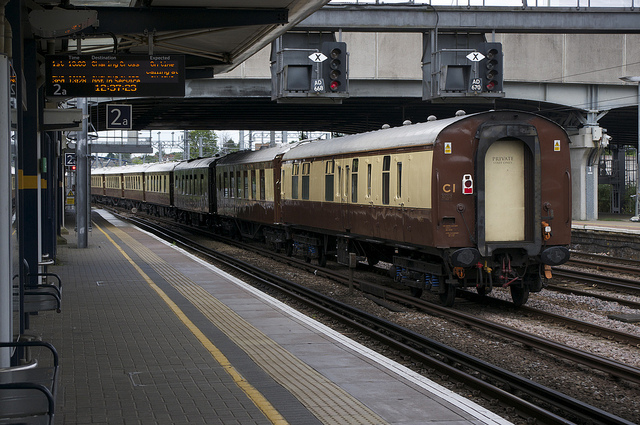<image>What does the sign say? I don't know what the sign says. It could say '2', '2a', 'train timings', 'destination and times', or '12:37'. What is this train's destination? It's unknown what this train's destination is. It could be various places like 'Denver', 'London', 'Moscow', or 'Cranberry'. What time is it? I don't know what time it is. The responses vary widely, ranging from specific times like '12:37:23' and '4:00' to more general times like 'noon' and 'afternoon'. What does the sign say? I am not sure what the sign says. It can be seen '2', '2a', 'destination and times', 'destinations', or '12:37'. What is this train's destination? It is unknown what is this train's destination. It can be seen 'north', 'denver', 'city', 'unknown', 'city', 'not possible', 'london', 'moscow', or 'cranberry'. What time is it? I don't know what time it is. It can be 12:37:23, noon, afternoon, 2, 4:00, 12:37, or 12:07. 